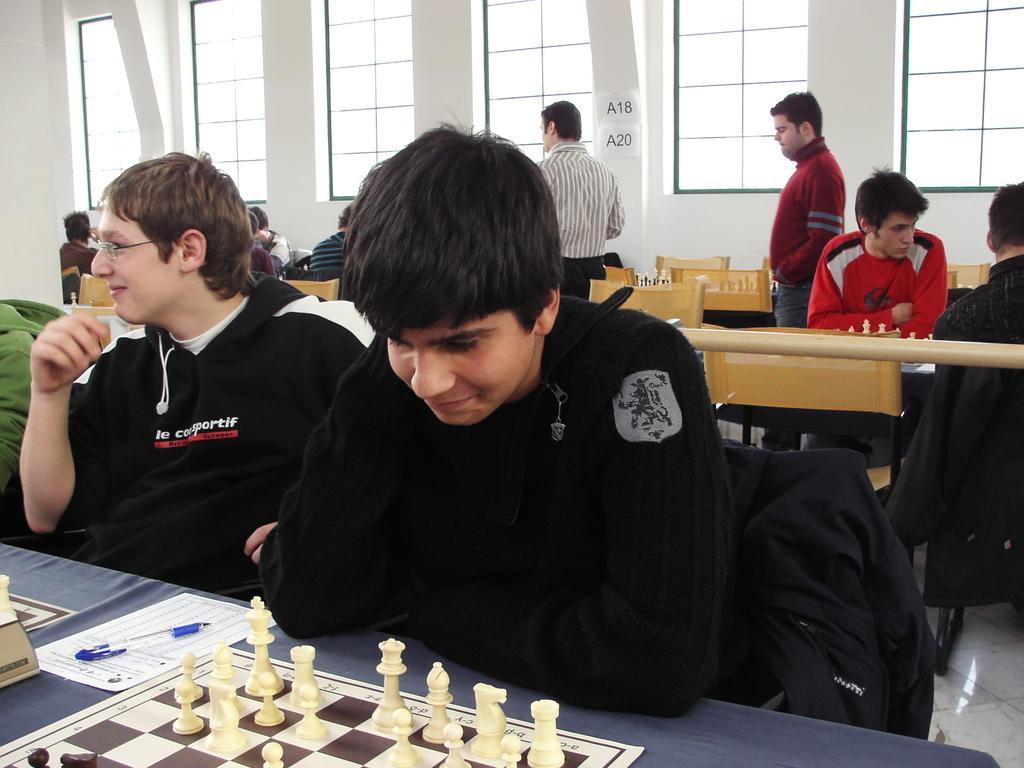In one or two sentences, can you explain what this image depicts? In this image we can see few people sitting on the chairs, there is a chess board with coins, a paper and a pen on the table, there are windows and posters to the wall in the background. 